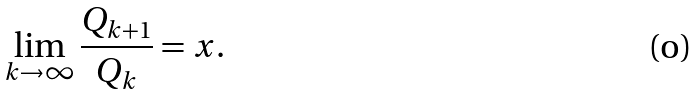Convert formula to latex. <formula><loc_0><loc_0><loc_500><loc_500>\lim _ { k \rightarrow \infty } \frac { Q _ { k + 1 } } { Q _ { k } } = x .</formula> 